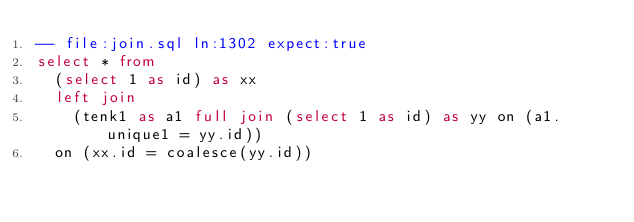<code> <loc_0><loc_0><loc_500><loc_500><_SQL_>-- file:join.sql ln:1302 expect:true
select * from
  (select 1 as id) as xx
  left join
    (tenk1 as a1 full join (select 1 as id) as yy on (a1.unique1 = yy.id))
  on (xx.id = coalesce(yy.id))
</code> 